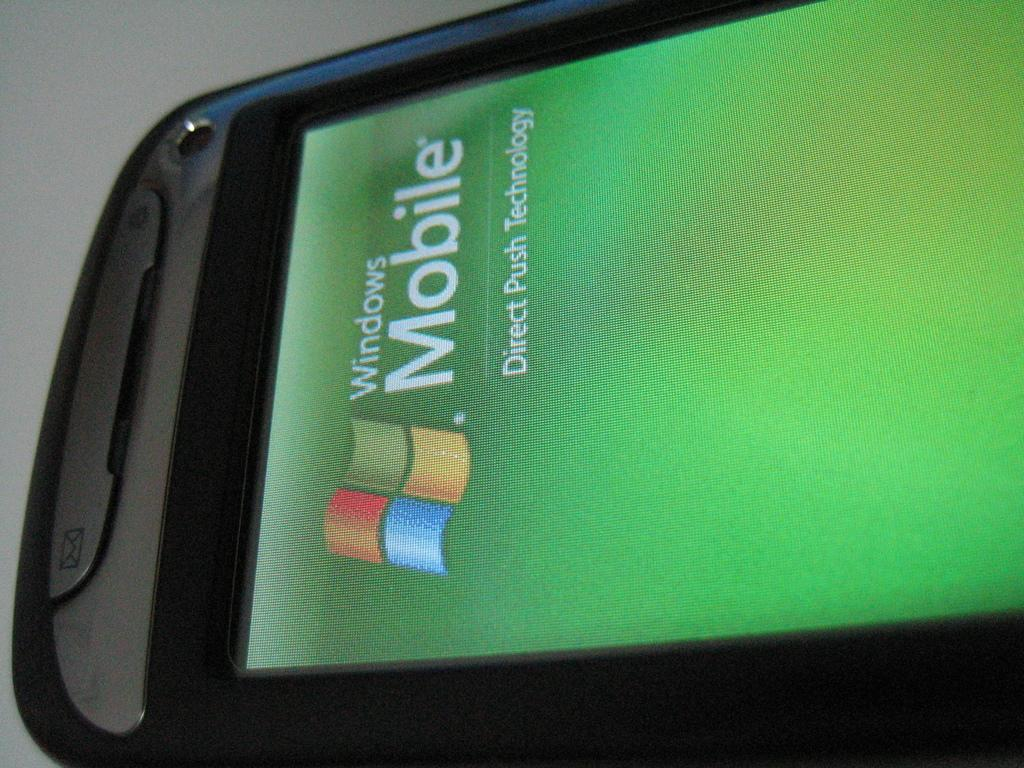<image>
Render a clear and concise summary of the photo. Part of a cell phone that has Windows Mobile on the screen display. 